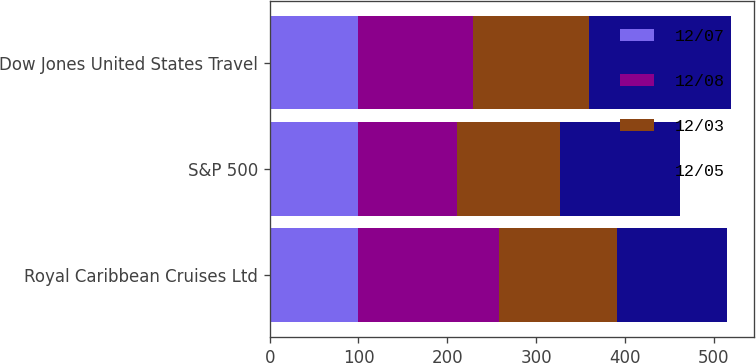<chart> <loc_0><loc_0><loc_500><loc_500><stacked_bar_chart><ecel><fcel>Royal Caribbean Cruises Ltd<fcel>S&P 500<fcel>Dow Jones United States Travel<nl><fcel>12/07<fcel>100<fcel>100<fcel>100<nl><fcel>12/08<fcel>158.32<fcel>110.88<fcel>128.53<nl><fcel>12/03<fcel>132.66<fcel>116.33<fcel>130.64<nl><fcel>12/05<fcel>123.67<fcel>134.7<fcel>159.96<nl></chart> 